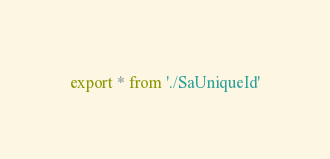<code> <loc_0><loc_0><loc_500><loc_500><_TypeScript_>export * from './SaUniqueId'
</code> 